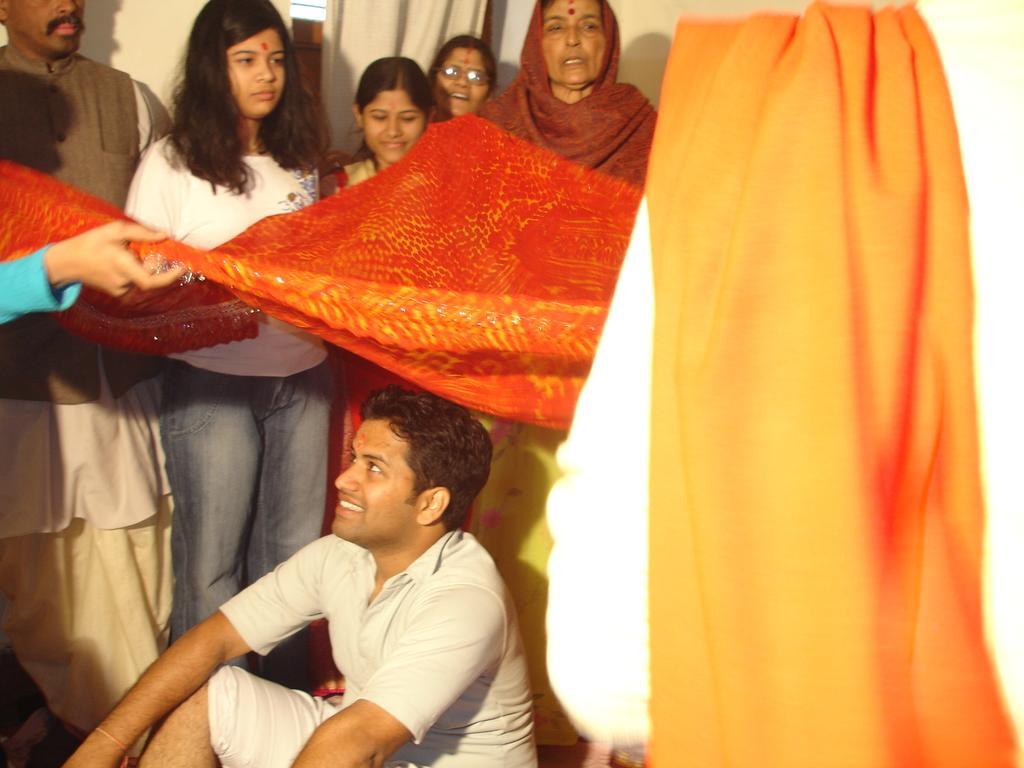How would you summarize this image in a sentence or two? At the bottom of the image there is a man sitting and he is smiling. Above him there is a cloth. There are few people standing. Behind them there is a wall and a curtain. 